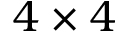<formula> <loc_0><loc_0><loc_500><loc_500>4 \times 4</formula> 